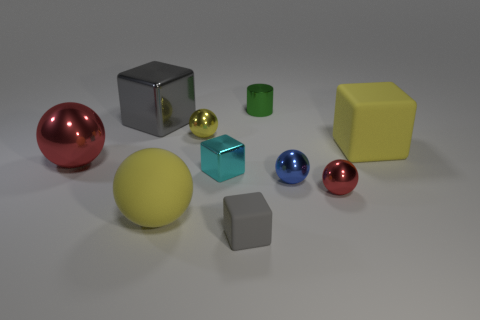Subtract all red cylinders. How many gray blocks are left? 2 Subtract all large gray metallic cubes. How many cubes are left? 3 Subtract 2 blocks. How many blocks are left? 2 Add 1 brown cubes. How many brown cubes exist? 1 Subtract all cyan cubes. How many cubes are left? 3 Subtract 0 purple cubes. How many objects are left? 10 Subtract all blocks. How many objects are left? 6 Subtract all yellow balls. Subtract all green cubes. How many balls are left? 3 Subtract all tiny purple cylinders. Subtract all tiny cyan metal things. How many objects are left? 9 Add 7 metallic blocks. How many metallic blocks are left? 9 